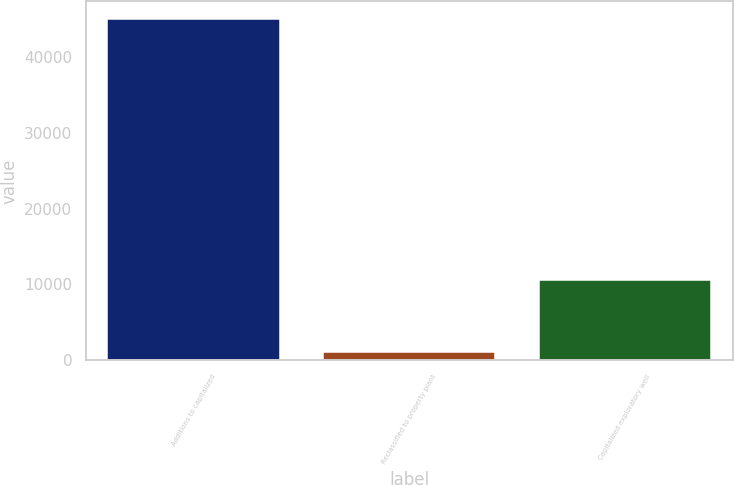Convert chart. <chart><loc_0><loc_0><loc_500><loc_500><bar_chart><fcel>Additions to capitalized<fcel>Reclassified to property plant<fcel>Capitalized exploratory well<nl><fcel>45011<fcel>1061<fcel>10601<nl></chart> 